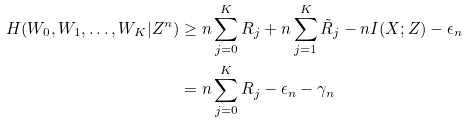<formula> <loc_0><loc_0><loc_500><loc_500>H ( W _ { 0 } , W _ { 1 } , \dots , W _ { K } | Z ^ { n } ) & \geq n \sum _ { j = 0 } ^ { K } R _ { j } + n \sum _ { j = 1 } ^ { K } \tilde { R } _ { j } - n I ( X ; Z ) - \epsilon _ { n } \\ & = n \sum _ { j = 0 } ^ { K } R _ { j } - \epsilon _ { n } - \gamma _ { n }</formula> 